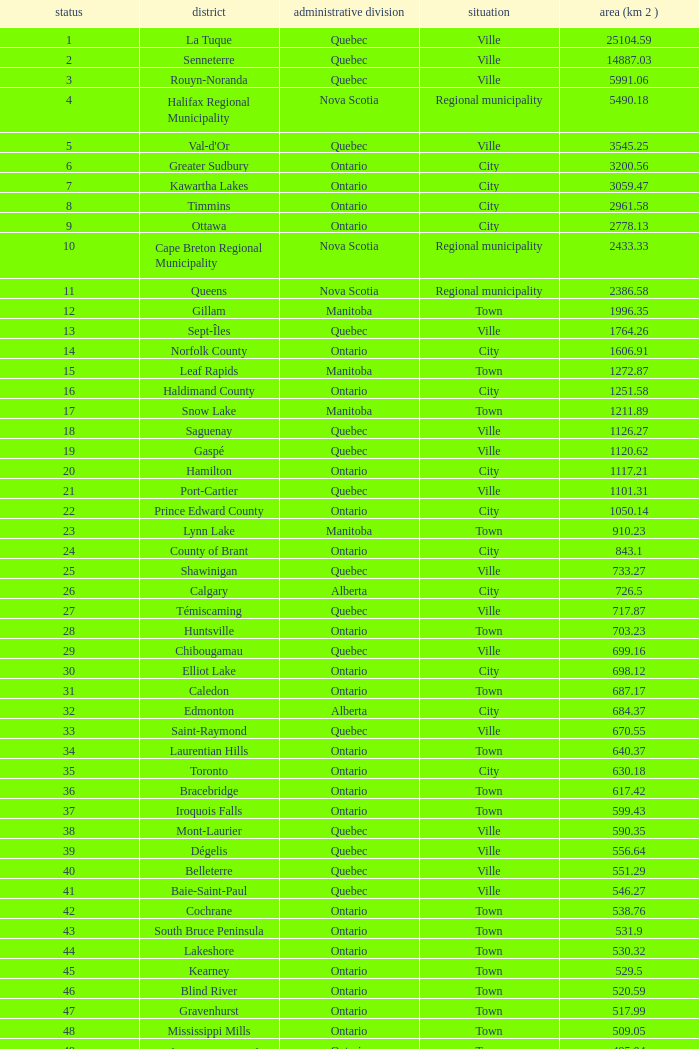What's the total of Rank that has an Area (KM 2) of 1050.14? 22.0. 